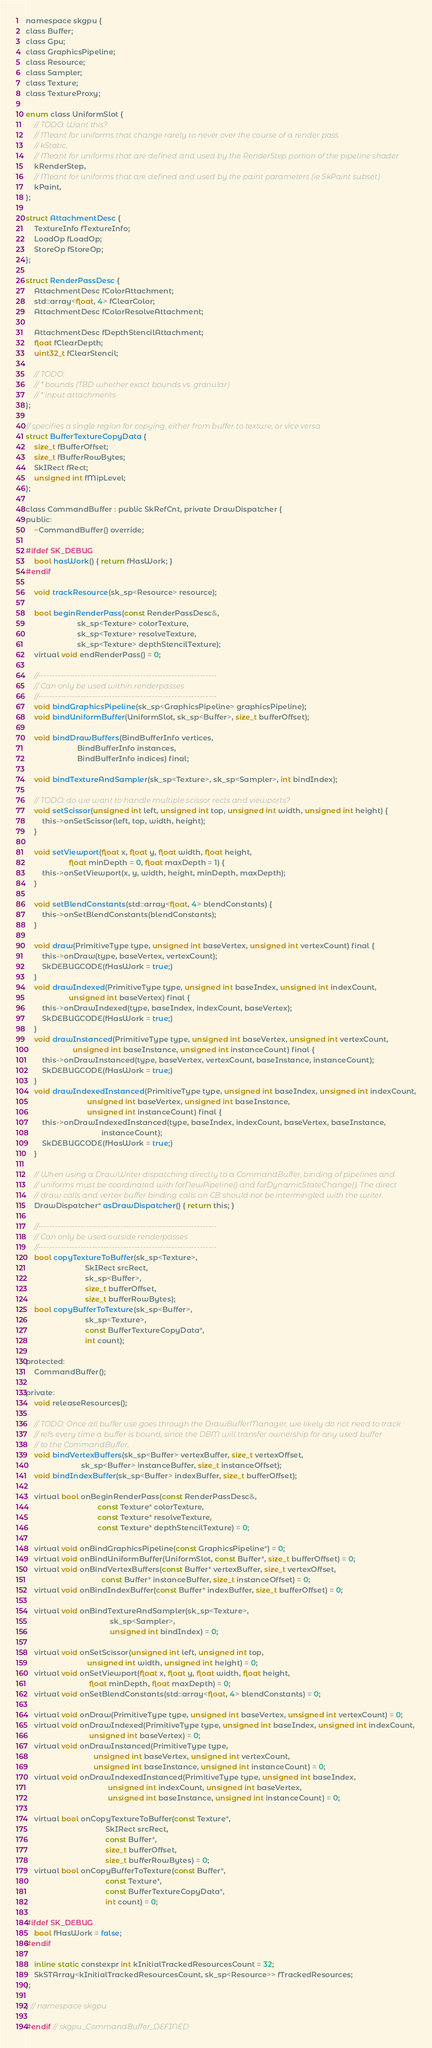<code> <loc_0><loc_0><loc_500><loc_500><_C_>
namespace skgpu {
class Buffer;
class Gpu;
class GraphicsPipeline;
class Resource;
class Sampler;
class Texture;
class TextureProxy;

enum class UniformSlot {
    // TODO: Want this?
    // Meant for uniforms that change rarely to never over the course of a render pass
    // kStatic,
    // Meant for uniforms that are defined and used by the RenderStep portion of the pipeline shader
    kRenderStep,
    // Meant for uniforms that are defined and used by the paint parameters (ie SkPaint subset)
    kPaint,
};

struct AttachmentDesc {
    TextureInfo fTextureInfo;
    LoadOp fLoadOp;
    StoreOp fStoreOp;
};

struct RenderPassDesc {
    AttachmentDesc fColorAttachment;
    std::array<float, 4> fClearColor;
    AttachmentDesc fColorResolveAttachment;

    AttachmentDesc fDepthStencilAttachment;
    float fClearDepth;
    uint32_t fClearStencil;

    // TODO:
    // * bounds (TBD whether exact bounds vs. granular)
    // * input attachments
};

// specifies a single region for copying, either from buffer to texture, or vice versa
struct BufferTextureCopyData {
    size_t fBufferOffset;
    size_t fBufferRowBytes;
    SkIRect fRect;
    unsigned int fMipLevel;
};

class CommandBuffer : public SkRefCnt, private DrawDispatcher {
public:
    ~CommandBuffer() override;

#ifdef SK_DEBUG
    bool hasWork() { return fHasWork; }
#endif

    void trackResource(sk_sp<Resource> resource);

    bool beginRenderPass(const RenderPassDesc&,
                         sk_sp<Texture> colorTexture,
                         sk_sp<Texture> resolveTexture,
                         sk_sp<Texture> depthStencilTexture);
    virtual void endRenderPass() = 0;

    //---------------------------------------------------------------
    // Can only be used within renderpasses
    //---------------------------------------------------------------
    void bindGraphicsPipeline(sk_sp<GraphicsPipeline> graphicsPipeline);
    void bindUniformBuffer(UniformSlot, sk_sp<Buffer>, size_t bufferOffset);

    void bindDrawBuffers(BindBufferInfo vertices,
                         BindBufferInfo instances,
                         BindBufferInfo indices) final;

    void bindTextureAndSampler(sk_sp<Texture>, sk_sp<Sampler>, int bindIndex);

    // TODO: do we want to handle multiple scissor rects and viewports?
    void setScissor(unsigned int left, unsigned int top, unsigned int width, unsigned int height) {
        this->onSetScissor(left, top, width, height);
    }

    void setViewport(float x, float y, float width, float height,
                     float minDepth = 0, float maxDepth = 1) {
        this->onSetViewport(x, y, width, height, minDepth, maxDepth);
    }

    void setBlendConstants(std::array<float, 4> blendConstants) {
        this->onSetBlendConstants(blendConstants);
    }

    void draw(PrimitiveType type, unsigned int baseVertex, unsigned int vertexCount) final {
        this->onDraw(type, baseVertex, vertexCount);
        SkDEBUGCODE(fHasWork = true;)
    }
    void drawIndexed(PrimitiveType type, unsigned int baseIndex, unsigned int indexCount,
                     unsigned int baseVertex) final {
        this->onDrawIndexed(type, baseIndex, indexCount, baseVertex);
        SkDEBUGCODE(fHasWork = true;)
    }
    void drawInstanced(PrimitiveType type, unsigned int baseVertex, unsigned int vertexCount,
                       unsigned int baseInstance, unsigned int instanceCount) final {
        this->onDrawInstanced(type, baseVertex, vertexCount, baseInstance, instanceCount);
        SkDEBUGCODE(fHasWork = true;)
    }
    void drawIndexedInstanced(PrimitiveType type, unsigned int baseIndex, unsigned int indexCount,
                              unsigned int baseVertex, unsigned int baseInstance,
                              unsigned int instanceCount) final {
        this->onDrawIndexedInstanced(type, baseIndex, indexCount, baseVertex, baseInstance,
                                     instanceCount);
        SkDEBUGCODE(fHasWork = true;)
    }

    // When using a DrawWriter dispatching directly to a CommandBuffer, binding of pipelines and
    // uniforms must be coordinated with forNewPipeline() and forDynamicStateChange(). The direct
    // draw calls and vertex buffer binding calls on CB should not be intermingled with the writer.
    DrawDispatcher* asDrawDispatcher() { return this; }

    //---------------------------------------------------------------
    // Can only be used outside renderpasses
    //---------------------------------------------------------------
    bool copyTextureToBuffer(sk_sp<Texture>,
                             SkIRect srcRect,
                             sk_sp<Buffer>,
                             size_t bufferOffset,
                             size_t bufferRowBytes);
    bool copyBufferToTexture(sk_sp<Buffer>,
                             sk_sp<Texture>,
                             const BufferTextureCopyData*,
                             int count);

protected:
    CommandBuffer();

private:
    void releaseResources();

    // TODO: Once all buffer use goes through the DrawBufferManager, we likely do not need to track
    // refs every time a buffer is bound, since the DBM will transfer ownership for any used buffer
    // to the CommandBuffer.
    void bindVertexBuffers(sk_sp<Buffer> vertexBuffer, size_t vertexOffset,
                           sk_sp<Buffer> instanceBuffer, size_t instanceOffset);
    void bindIndexBuffer(sk_sp<Buffer> indexBuffer, size_t bufferOffset);

    virtual bool onBeginRenderPass(const RenderPassDesc&,
                                   const Texture* colorTexture,
                                   const Texture* resolveTexture,
                                   const Texture* depthStencilTexture) = 0;

    virtual void onBindGraphicsPipeline(const GraphicsPipeline*) = 0;
    virtual void onBindUniformBuffer(UniformSlot, const Buffer*, size_t bufferOffset) = 0;
    virtual void onBindVertexBuffers(const Buffer* vertexBuffer, size_t vertexOffset,
                                     const Buffer* instanceBuffer, size_t instanceOffset) = 0;
    virtual void onBindIndexBuffer(const Buffer* indexBuffer, size_t bufferOffset) = 0;

    virtual void onBindTextureAndSampler(sk_sp<Texture>,
                                         sk_sp<Sampler>,
                                         unsigned int bindIndex) = 0;

    virtual void onSetScissor(unsigned int left, unsigned int top,
                              unsigned int width, unsigned int height) = 0;
    virtual void onSetViewport(float x, float y, float width, float height,
                               float minDepth, float maxDepth) = 0;
    virtual void onSetBlendConstants(std::array<float, 4> blendConstants) = 0;

    virtual void onDraw(PrimitiveType type, unsigned int baseVertex, unsigned int vertexCount) = 0;
    virtual void onDrawIndexed(PrimitiveType type, unsigned int baseIndex, unsigned int indexCount,
                               unsigned int baseVertex) = 0;
    virtual void onDrawInstanced(PrimitiveType type,
                                 unsigned int baseVertex, unsigned int vertexCount,
                                 unsigned int baseInstance, unsigned int instanceCount) = 0;
    virtual void onDrawIndexedInstanced(PrimitiveType type, unsigned int baseIndex,
                                        unsigned int indexCount, unsigned int baseVertex,
                                        unsigned int baseInstance, unsigned int instanceCount) = 0;

    virtual bool onCopyTextureToBuffer(const Texture*,
                                       SkIRect srcRect,
                                       const Buffer*,
                                       size_t bufferOffset,
                                       size_t bufferRowBytes) = 0;
    virtual bool onCopyBufferToTexture(const Buffer*,
                                       const Texture*,
                                       const BufferTextureCopyData*,
                                       int count) = 0;

#ifdef SK_DEBUG
    bool fHasWork = false;
#endif

    inline static constexpr int kInitialTrackedResourcesCount = 32;
    SkSTArray<kInitialTrackedResourcesCount, sk_sp<Resource>> fTrackedResources;
};

} // namespace skgpu

#endif // skgpu_CommandBuffer_DEFINED
</code> 